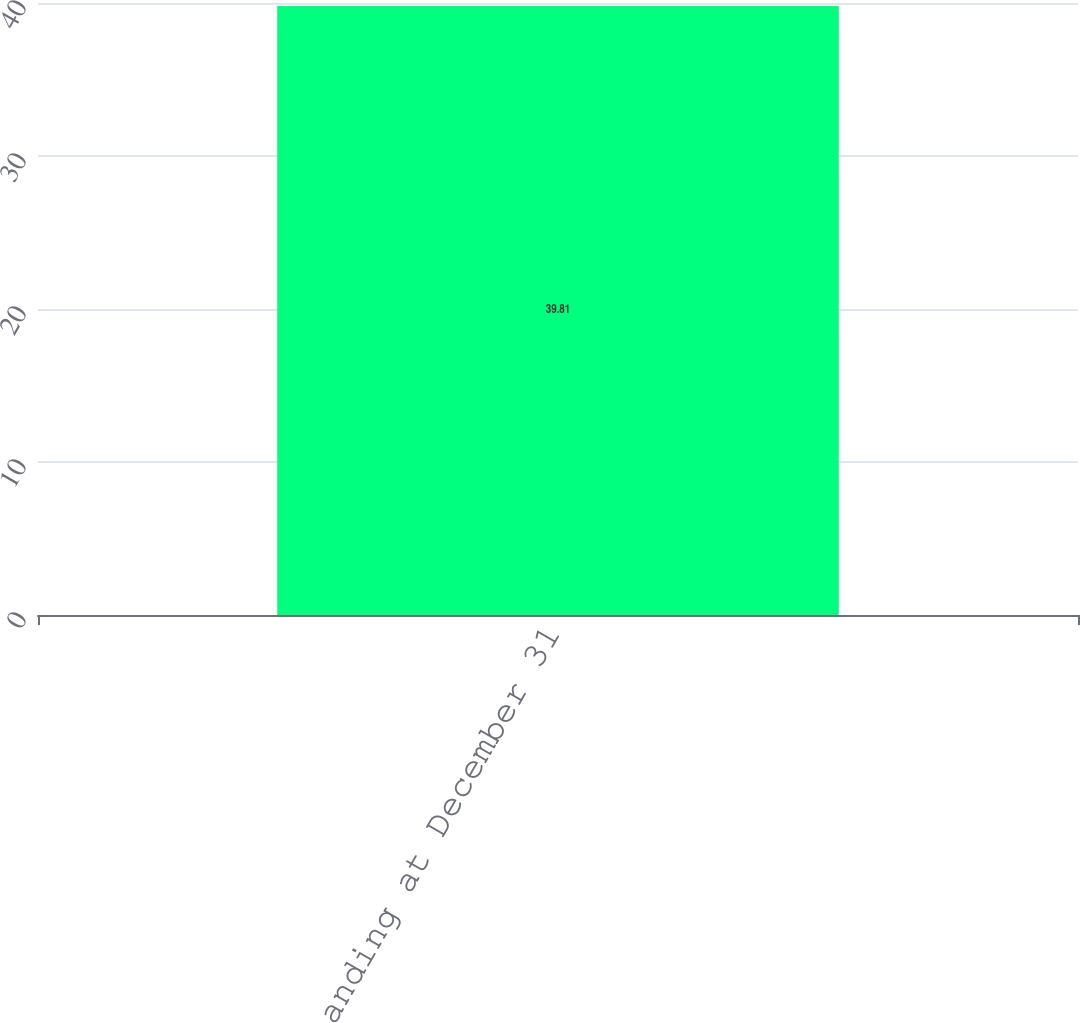<chart> <loc_0><loc_0><loc_500><loc_500><bar_chart><fcel>Outstanding at December 31<nl><fcel>39.81<nl></chart> 